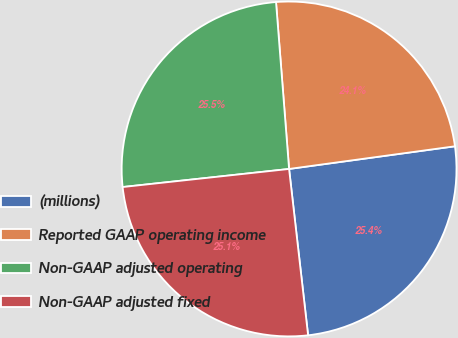Convert chart to OTSL. <chart><loc_0><loc_0><loc_500><loc_500><pie_chart><fcel>(millions)<fcel>Reported GAAP operating income<fcel>Non-GAAP adjusted operating<fcel>Non-GAAP adjusted fixed<nl><fcel>25.35%<fcel>24.08%<fcel>25.48%<fcel>25.09%<nl></chart> 